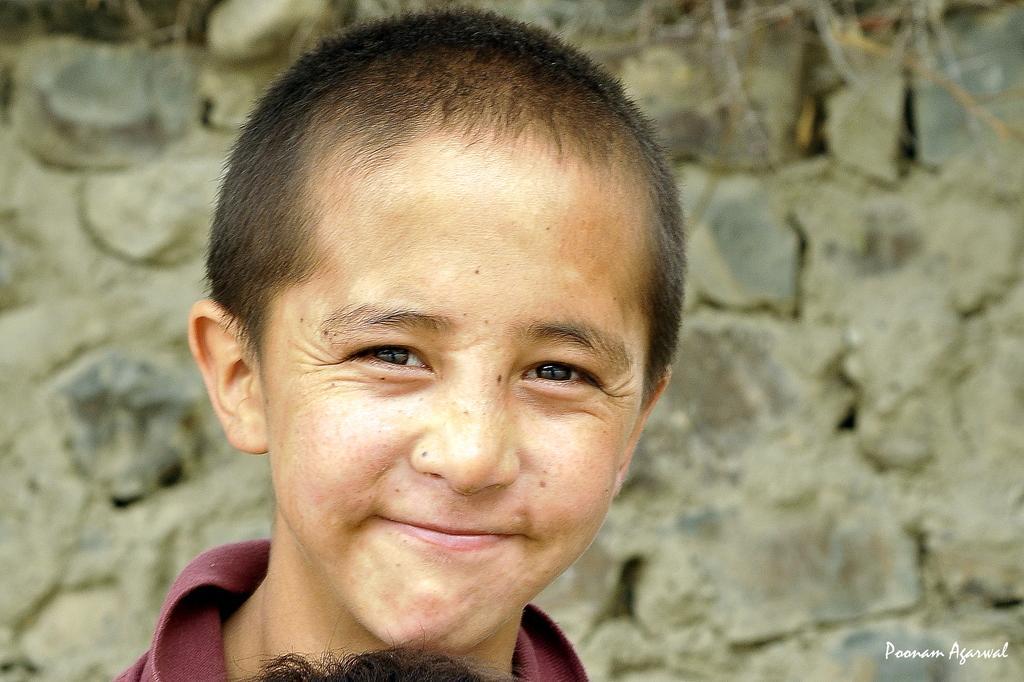Please provide a concise description of this image. In the image there is a boy and the background of the boy is blur. 